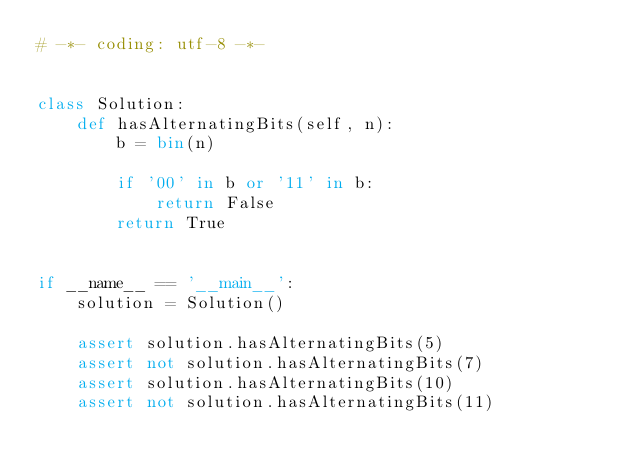<code> <loc_0><loc_0><loc_500><loc_500><_Python_># -*- coding: utf-8 -*-


class Solution:
    def hasAlternatingBits(self, n):
        b = bin(n)

        if '00' in b or '11' in b:
            return False
        return True


if __name__ == '__main__':
    solution = Solution()

    assert solution.hasAlternatingBits(5)
    assert not solution.hasAlternatingBits(7)
    assert solution.hasAlternatingBits(10)
    assert not solution.hasAlternatingBits(11)
</code> 